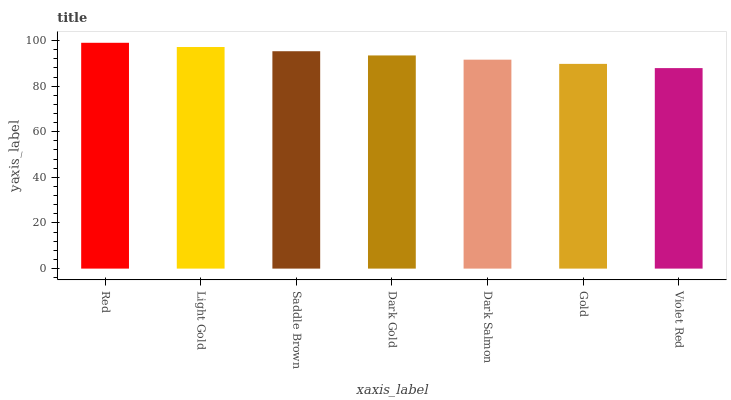Is Violet Red the minimum?
Answer yes or no. Yes. Is Red the maximum?
Answer yes or no. Yes. Is Light Gold the minimum?
Answer yes or no. No. Is Light Gold the maximum?
Answer yes or no. No. Is Red greater than Light Gold?
Answer yes or no. Yes. Is Light Gold less than Red?
Answer yes or no. Yes. Is Light Gold greater than Red?
Answer yes or no. No. Is Red less than Light Gold?
Answer yes or no. No. Is Dark Gold the high median?
Answer yes or no. Yes. Is Dark Gold the low median?
Answer yes or no. Yes. Is Violet Red the high median?
Answer yes or no. No. Is Violet Red the low median?
Answer yes or no. No. 